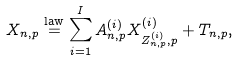<formula> <loc_0><loc_0><loc_500><loc_500>X _ { n , p } & \overset { \text {law} } { = } \sum _ { i = 1 } ^ { I } A ^ { ( i ) } _ { n , p } X ^ { ( i ) } _ { Z ^ { ( i ) } _ { n , p } , p } + T _ { n , p } ,</formula> 